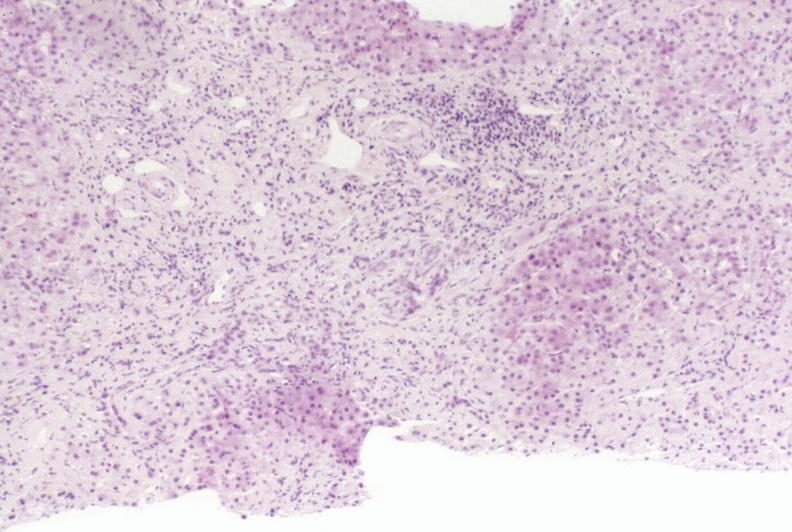what does this image show?
Answer the question using a single word or phrase. Primary sclerosing cholangitis 